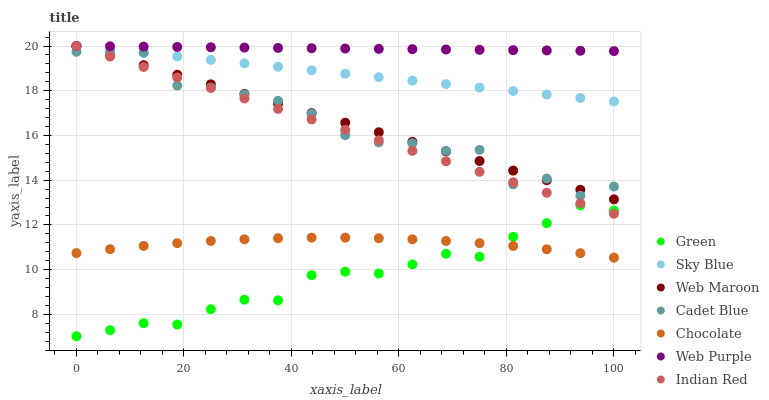Does Green have the minimum area under the curve?
Answer yes or no. Yes. Does Web Purple have the maximum area under the curve?
Answer yes or no. Yes. Does Web Maroon have the minimum area under the curve?
Answer yes or no. No. Does Web Maroon have the maximum area under the curve?
Answer yes or no. No. Is Web Purple the smoothest?
Answer yes or no. Yes. Is Cadet Blue the roughest?
Answer yes or no. Yes. Is Web Maroon the smoothest?
Answer yes or no. No. Is Web Maroon the roughest?
Answer yes or no. No. Does Green have the lowest value?
Answer yes or no. Yes. Does Web Maroon have the lowest value?
Answer yes or no. No. Does Sky Blue have the highest value?
Answer yes or no. Yes. Does Chocolate have the highest value?
Answer yes or no. No. Is Green less than Sky Blue?
Answer yes or no. Yes. Is Web Purple greater than Green?
Answer yes or no. Yes. Does Web Maroon intersect Web Purple?
Answer yes or no. Yes. Is Web Maroon less than Web Purple?
Answer yes or no. No. Is Web Maroon greater than Web Purple?
Answer yes or no. No. Does Green intersect Sky Blue?
Answer yes or no. No. 